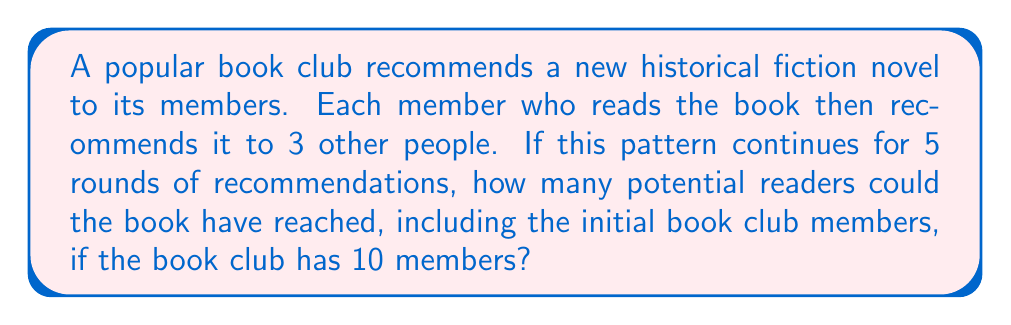Show me your answer to this math problem. Let's approach this step-by-step:

1) Start with the initial number of readers (book club members):
   $n_0 = 10$

2) In each round, each reader recommends to 3 new people. This means the number of new readers in each round is 3 times the number of readers in the previous round.

3) We can represent this as a geometric sequence with a common ratio of 3:
   $n_1 = 10 \cdot 3 = 30$
   $n_2 = 30 \cdot 3 = 90$
   $n_3 = 90 \cdot 3 = 270$
   $n_4 = 270 \cdot 3 = 810$
   $n_5 = 810 \cdot 3 = 2430$

4) To find the total number of potential readers, we need to sum all these numbers:
   $Total = n_0 + n_1 + n_2 + n_3 + n_4 + n_5$

5) We can use the formula for the sum of a geometric sequence:
   $S_n = a\frac{1-r^{n+1}}{1-r}$, where $a$ is the first term, $r$ is the common ratio, and $n$ is the number of terms.

6) In our case, $a=10$, $r=3$, and $n=5$:
   $$S_5 = 10\frac{1-3^6}{1-3} = 10\frac{1-729}{-2} = 10 \cdot 364 = 3640$$

Therefore, the book could potentially reach 3,640 readers.
Answer: 3,640 readers 